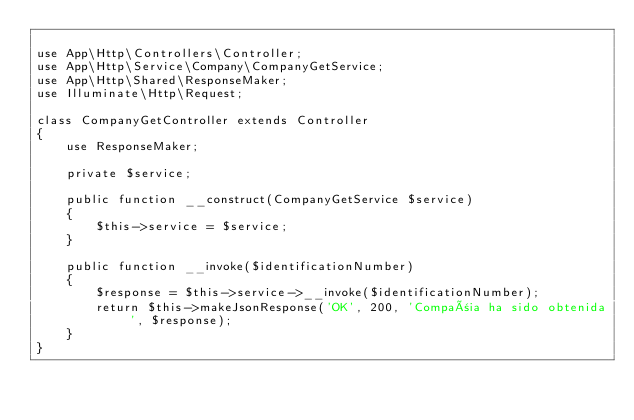Convert code to text. <code><loc_0><loc_0><loc_500><loc_500><_PHP_>
use App\Http\Controllers\Controller;
use App\Http\Service\Company\CompanyGetService;
use App\Http\Shared\ResponseMaker;
use Illuminate\Http\Request;

class CompanyGetController extends Controller
{
    use ResponseMaker;

    private $service;

    public function __construct(CompanyGetService $service)
    {
        $this->service = $service;
    }

    public function __invoke($identificationNumber)
    {
        $response = $this->service->__invoke($identificationNumber);
        return $this->makeJsonResponse('OK', 200, 'Compañia ha sido obtenida', $response);
    }
}
</code> 